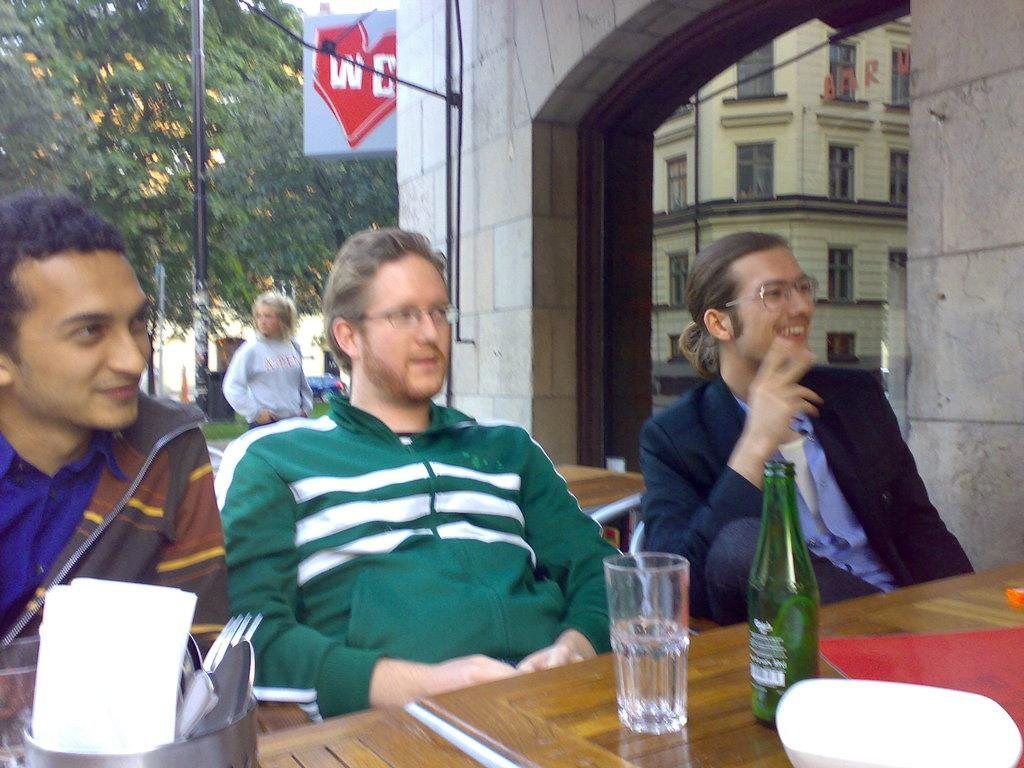How many men are in the image? There are three men in the image. What are the men doing in the image? The men are sitting on chairs. Can you describe the facial expression of the man on the right side? The man on the right side is smiling. What can be seen in the background of the image? There is a tree and a woman in the background of the image. Where is the nest located in the image? There is no nest present in the image. What does the woman in the background of the image regret? There is no indication of regret in the image, and the woman's emotions or thoughts are not visible. 